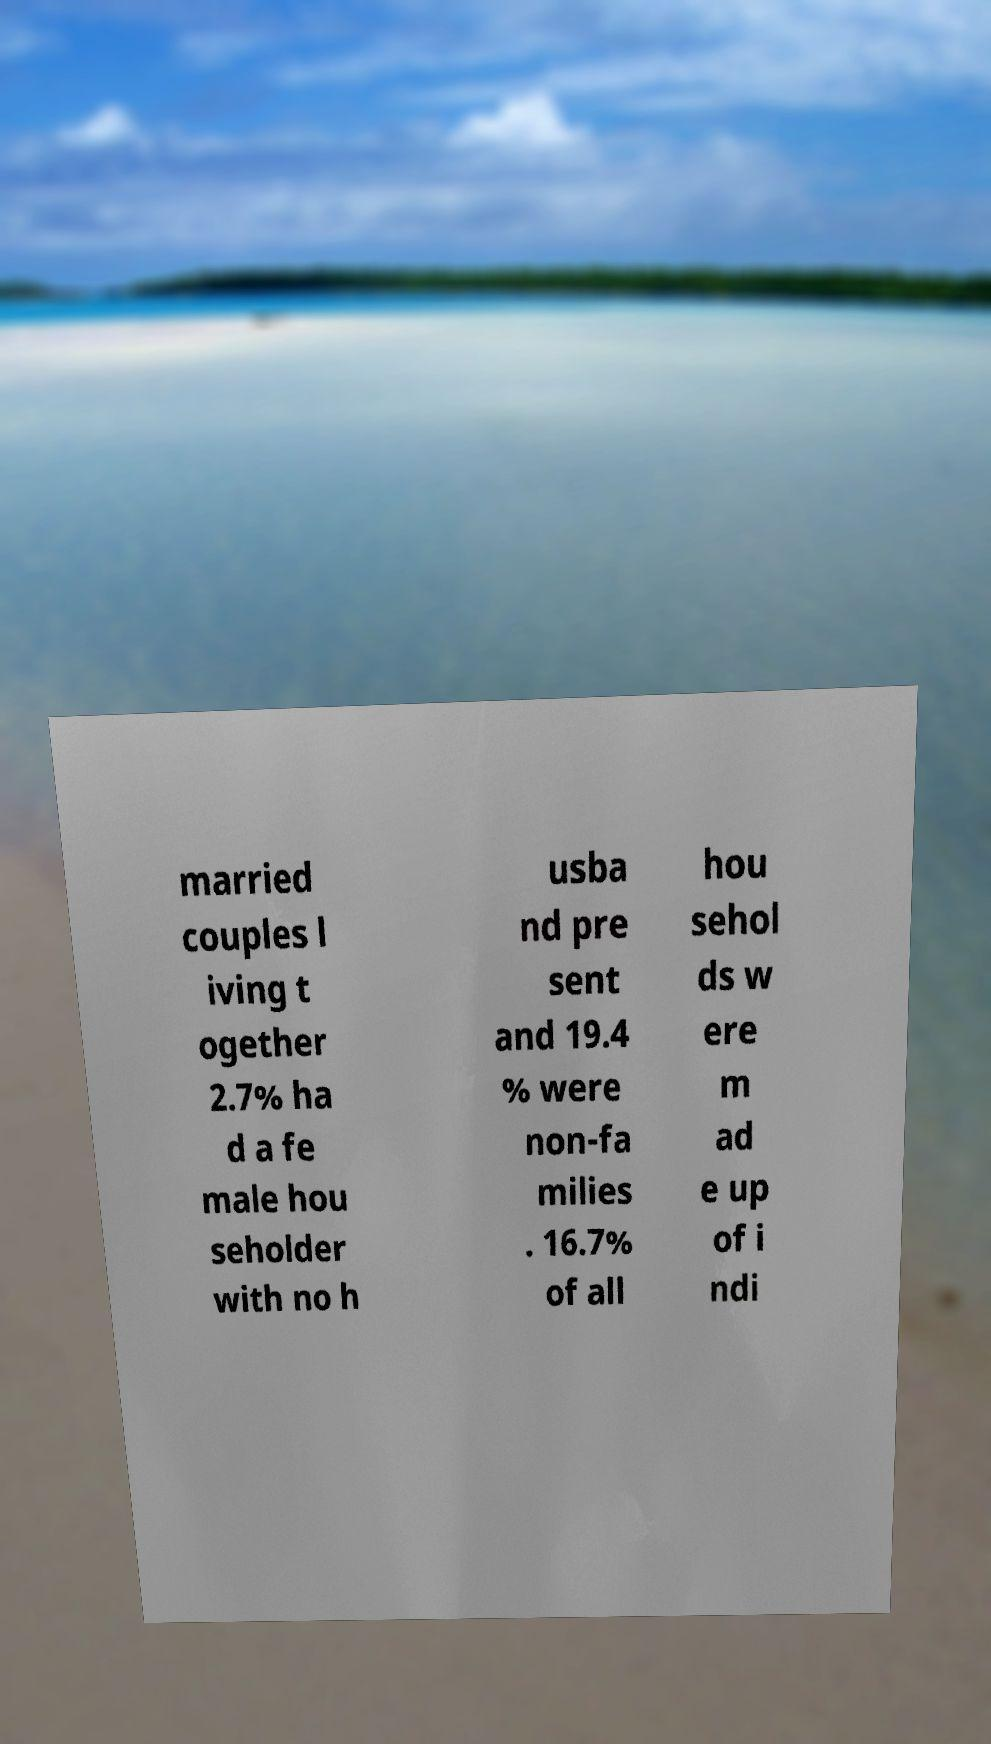Could you extract and type out the text from this image? married couples l iving t ogether 2.7% ha d a fe male hou seholder with no h usba nd pre sent and 19.4 % were non-fa milies . 16.7% of all hou sehol ds w ere m ad e up of i ndi 